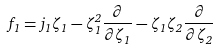Convert formula to latex. <formula><loc_0><loc_0><loc_500><loc_500>f _ { 1 } = j _ { 1 } \zeta _ { 1 } - \zeta _ { 1 } ^ { 2 } \frac { \partial } { \partial \zeta _ { 1 } } - \zeta _ { 1 } \zeta _ { 2 } \frac { \partial } { \partial \zeta _ { 2 } }</formula> 